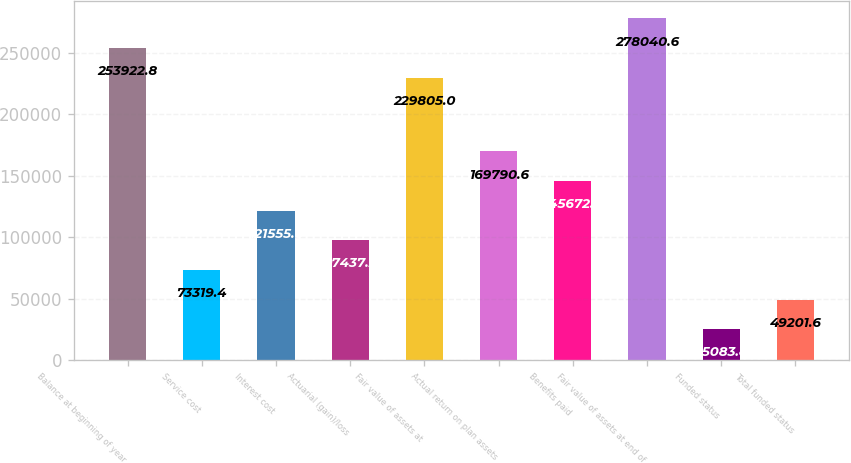Convert chart. <chart><loc_0><loc_0><loc_500><loc_500><bar_chart><fcel>Balance at beginning of year<fcel>Service cost<fcel>Interest cost<fcel>Actuarial (gain)/loss<fcel>Fair value of assets at<fcel>Actual return on plan assets<fcel>Benefits paid<fcel>Fair value of assets at end of<fcel>Funded status<fcel>Total funded status<nl><fcel>253923<fcel>73319.4<fcel>121555<fcel>97437.2<fcel>229805<fcel>169791<fcel>145673<fcel>278041<fcel>25083.8<fcel>49201.6<nl></chart> 